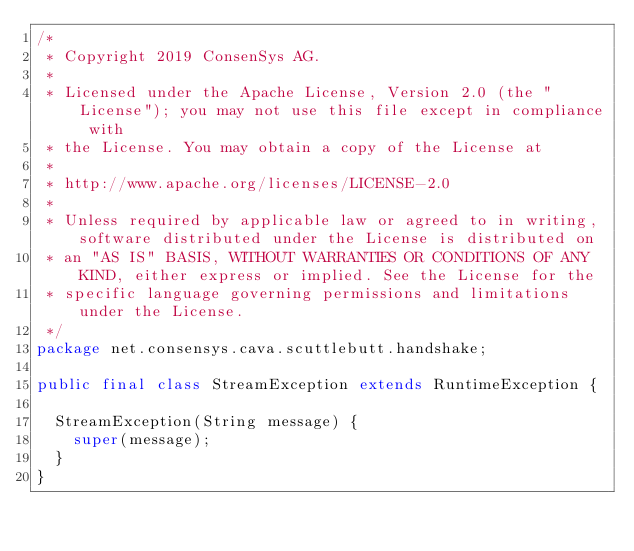<code> <loc_0><loc_0><loc_500><loc_500><_Java_>/*
 * Copyright 2019 ConsenSys AG.
 *
 * Licensed under the Apache License, Version 2.0 (the "License"); you may not use this file except in compliance with
 * the License. You may obtain a copy of the License at
 *
 * http://www.apache.org/licenses/LICENSE-2.0
 *
 * Unless required by applicable law or agreed to in writing, software distributed under the License is distributed on
 * an "AS IS" BASIS, WITHOUT WARRANTIES OR CONDITIONS OF ANY KIND, either express or implied. See the License for the
 * specific language governing permissions and limitations under the License.
 */
package net.consensys.cava.scuttlebutt.handshake;

public final class StreamException extends RuntimeException {

  StreamException(String message) {
    super(message);
  }
}
</code> 